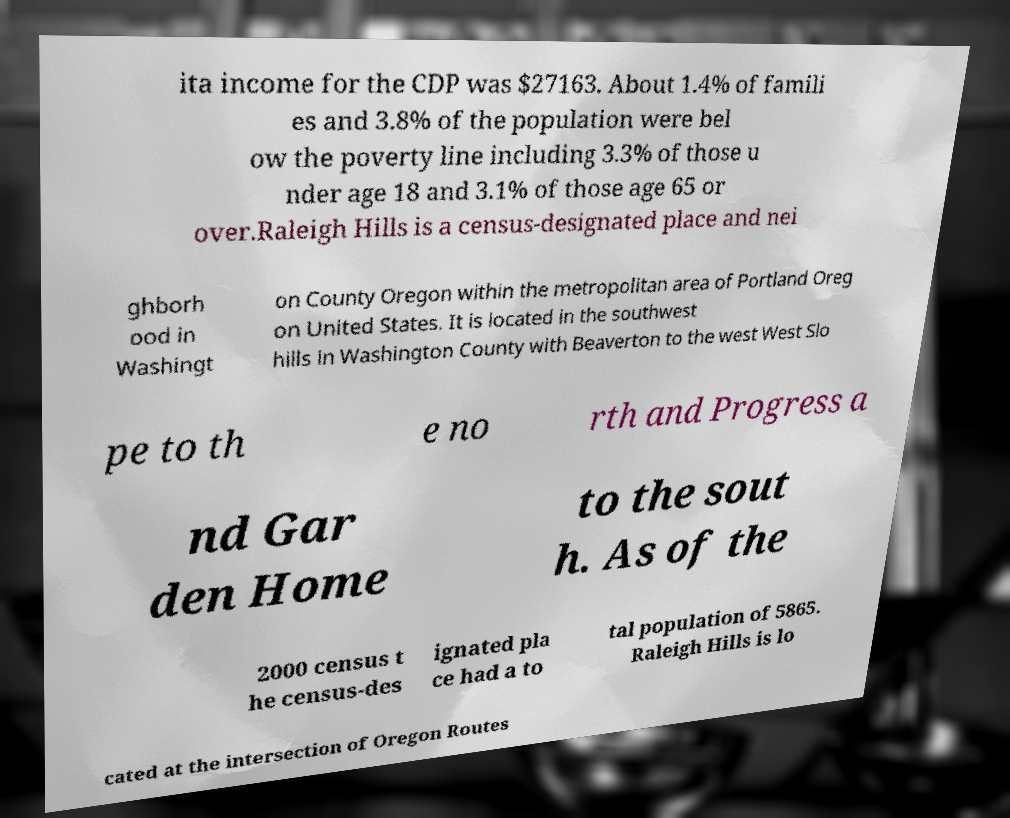For documentation purposes, I need the text within this image transcribed. Could you provide that? ita income for the CDP was $27163. About 1.4% of famili es and 3.8% of the population were bel ow the poverty line including 3.3% of those u nder age 18 and 3.1% of those age 65 or over.Raleigh Hills is a census-designated place and nei ghborh ood in Washingt on County Oregon within the metropolitan area of Portland Oreg on United States. It is located in the southwest hills in Washington County with Beaverton to the west West Slo pe to th e no rth and Progress a nd Gar den Home to the sout h. As of the 2000 census t he census-des ignated pla ce had a to tal population of 5865. Raleigh Hills is lo cated at the intersection of Oregon Routes 